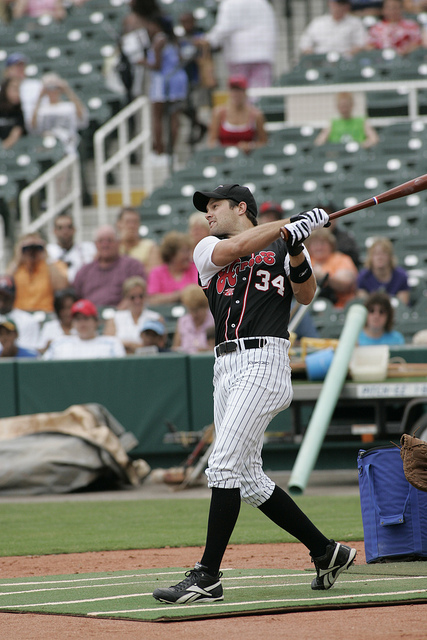Read and extract the text from this image. 34 